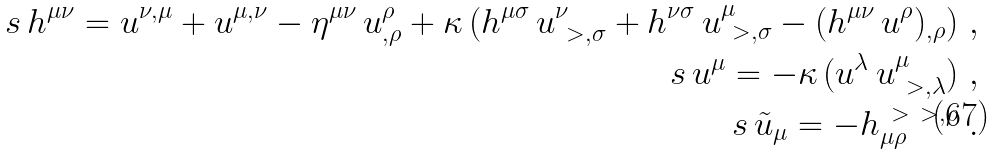Convert formula to latex. <formula><loc_0><loc_0><loc_500><loc_500>s \, h ^ { \mu \nu } = u ^ { \nu , \mu } + u ^ { \mu , \nu } - \eta ^ { \mu \nu } \, u ^ { \rho } _ { , \rho } + \kappa \, ( h ^ { \mu \sigma } \, u ^ { \nu } _ { \ > , \sigma } + h ^ { \nu \sigma } \, u ^ { \mu } _ { \ > , \sigma } - ( h ^ { \mu \nu } \, u ^ { \rho } ) _ { , \rho } ) \ , \\ s \, u ^ { \mu } = - \kappa \, ( u ^ { \lambda } \, u ^ { \mu } _ { \ > , \lambda } ) \ , \\ s \, \tilde { u } _ { \mu } = - h _ { \mu \rho } ^ { \ > \ > , \rho } \ .</formula> 